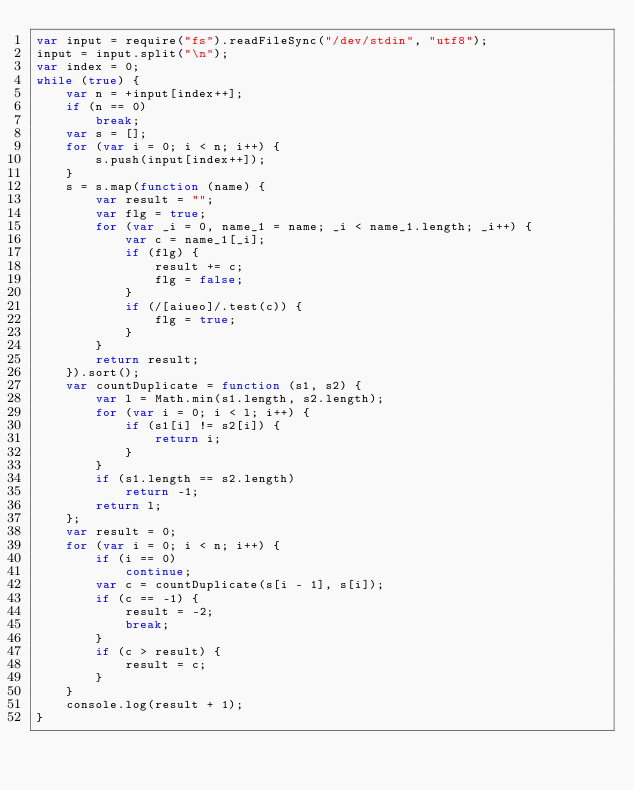<code> <loc_0><loc_0><loc_500><loc_500><_JavaScript_>var input = require("fs").readFileSync("/dev/stdin", "utf8");
input = input.split("\n");
var index = 0;
while (true) {
    var n = +input[index++];
    if (n == 0)
        break;
    var s = [];
    for (var i = 0; i < n; i++) {
        s.push(input[index++]);
    }
    s = s.map(function (name) {
        var result = "";
        var flg = true;
        for (var _i = 0, name_1 = name; _i < name_1.length; _i++) {
            var c = name_1[_i];
            if (flg) {
                result += c;
                flg = false;
            }
            if (/[aiueo]/.test(c)) {
                flg = true;
            }
        }
        return result;
    }).sort();
    var countDuplicate = function (s1, s2) {
        var l = Math.min(s1.length, s2.length);
        for (var i = 0; i < l; i++) {
            if (s1[i] != s2[i]) {
                return i;
            }
        }
        if (s1.length == s2.length)
            return -1;
        return l;
    };
    var result = 0;
    for (var i = 0; i < n; i++) {
        if (i == 0)
            continue;
        var c = countDuplicate(s[i - 1], s[i]);
        if (c == -1) {
            result = -2;
            break;
        }
        if (c > result) {
            result = c;
        }
    }
    console.log(result + 1);
}</code> 